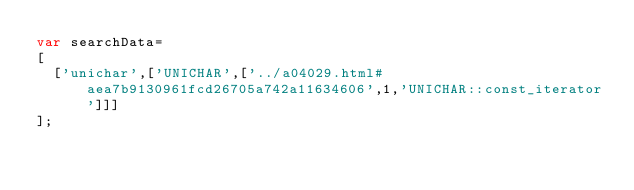<code> <loc_0><loc_0><loc_500><loc_500><_JavaScript_>var searchData=
[
  ['unichar',['UNICHAR',['../a04029.html#aea7b9130961fcd26705a742a11634606',1,'UNICHAR::const_iterator']]]
];
</code> 